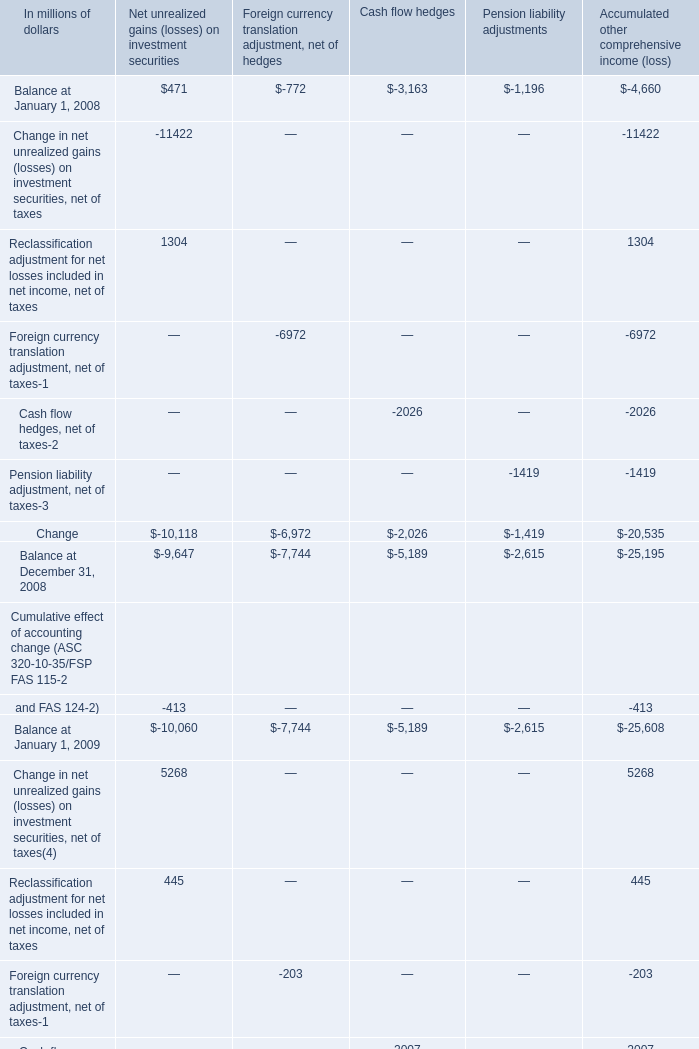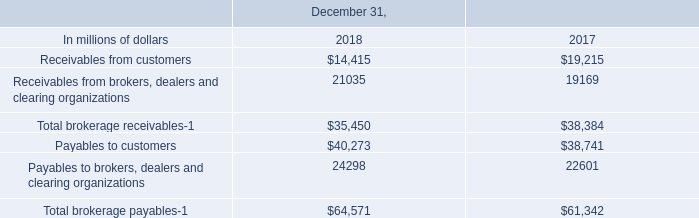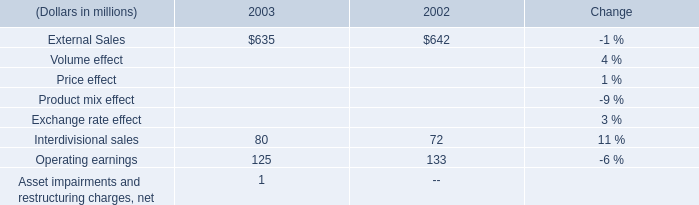What is the sum of Payables to customers of December 31, 2017, and Balance at December 31, 2008 of Pension liability adjustments ? 
Computations: (38741.0 + 2615.0)
Answer: 41356.0. 